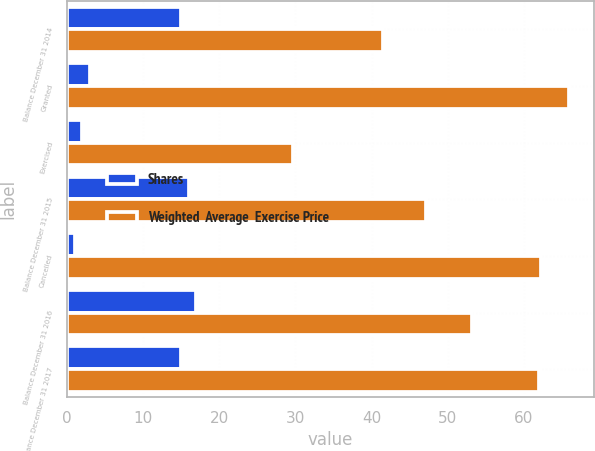Convert chart to OTSL. <chart><loc_0><loc_0><loc_500><loc_500><stacked_bar_chart><ecel><fcel>Balance December 31 2014<fcel>Granted<fcel>Exercised<fcel>Balance December 31 2015<fcel>Cancelled<fcel>Balance December 31 2016<fcel>Balance December 31 2017<nl><fcel>Shares<fcel>15<fcel>3<fcel>2<fcel>16<fcel>1<fcel>17<fcel>15<nl><fcel>Weighted  Average  Exercise Price<fcel>41.56<fcel>65.91<fcel>29.67<fcel>47.19<fcel>62.25<fcel>53.21<fcel>61.97<nl></chart> 